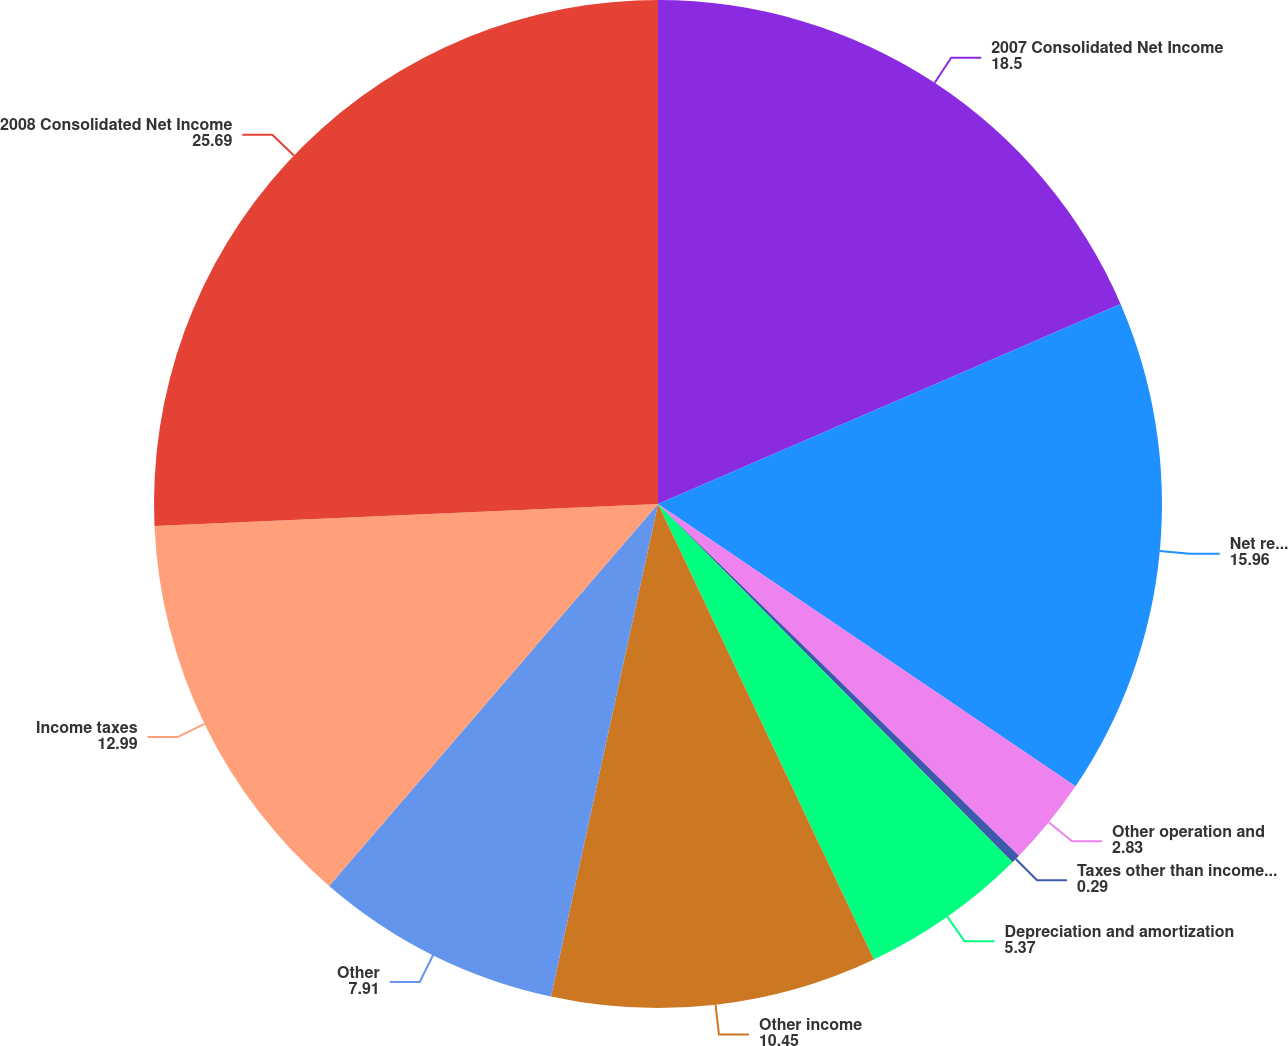Convert chart. <chart><loc_0><loc_0><loc_500><loc_500><pie_chart><fcel>2007 Consolidated Net Income<fcel>Net revenue (operating revenue<fcel>Other operation and<fcel>Taxes other than income taxes<fcel>Depreciation and amortization<fcel>Other income<fcel>Other<fcel>Income taxes<fcel>2008 Consolidated Net Income<nl><fcel>18.5%<fcel>15.96%<fcel>2.83%<fcel>0.29%<fcel>5.37%<fcel>10.45%<fcel>7.91%<fcel>12.99%<fcel>25.69%<nl></chart> 